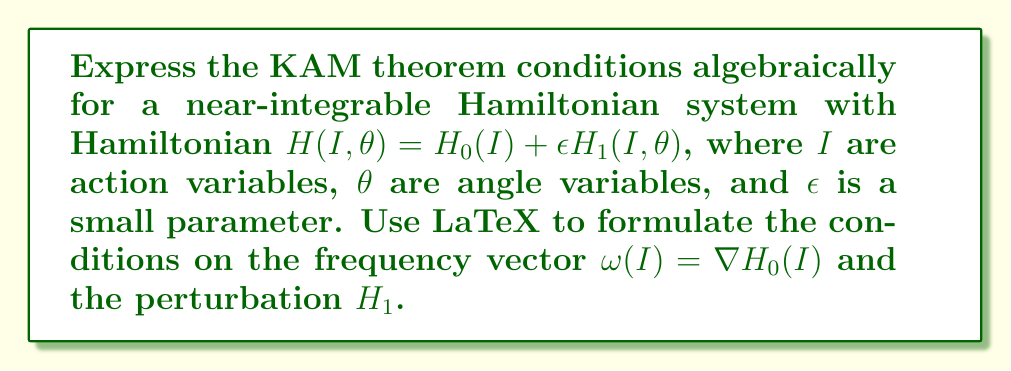Teach me how to tackle this problem. To express the KAM theorem conditions algebraically, we need to consider the following steps:

1) First, we define the frequency vector $\omega(I)$ as the gradient of the unperturbed Hamiltonian:

   $$\omega(I) = \nabla H_0(I) = \left(\frac{\partial H_0}{\partial I_1}, \frac{\partial H_0}{\partial I_2}, \ldots, \frac{\partial H_0}{\partial I_n}\right)$$

2) The non-degeneracy condition: The frequency map should be a local diffeomorphism. This is equivalent to requiring that the determinant of the Hessian of $H_0$ is non-zero:

   $$\det\left(\frac{\partial^2 H_0}{\partial I_i \partial I_j}\right) \neq 0$$

3) The Diophantine condition: For some $\gamma > 0$ and $\tau > n-1$, the frequency vector should satisfy:

   $$|\langle k, \omega(I) \rangle| \geq \frac{\gamma}{|k|^\tau}$$

   for all $k \in \mathbb{Z}^n \setminus \{0\}$, where $\langle \cdot, \cdot \rangle$ denotes the inner product and $|k| = \sum_{i=1}^n |k_i|$.

4) Smoothness conditions: Both $H_0$ and $H_1$ should be sufficiently smooth. Typically, we require them to be at least $C^r$ with $r > 2\tau + 2$.

5) Smallness condition on the perturbation: There exists a constant $C > 0$ such that:

   $$\|\epsilon H_1\|_{C^r} \leq C\epsilon$$

   where $\|\cdot\|_{C^r}$ denotes the $C^r$ norm.

These conditions ensure that for sufficiently small $\epsilon$, most of the invariant tori of the integrable system $H_0$ persist as slightly deformed tori in the perturbed system $H$.
Answer: $$\begin{cases}
\det\left(\frac{\partial^2 H_0}{\partial I_i \partial I_j}\right) \neq 0 \\
|\langle k, \nabla H_0(I) \rangle| \geq \frac{\gamma}{|k|^\tau}, \gamma > 0, \tau > n-1, \forall k \in \mathbb{Z}^n \setminus \{0\} \\
H_0, H_1 \in C^r, r > 2\tau + 2 \\
\|\epsilon H_1\|_{C^r} \leq C\epsilon, C > 0
\end{cases}$$ 